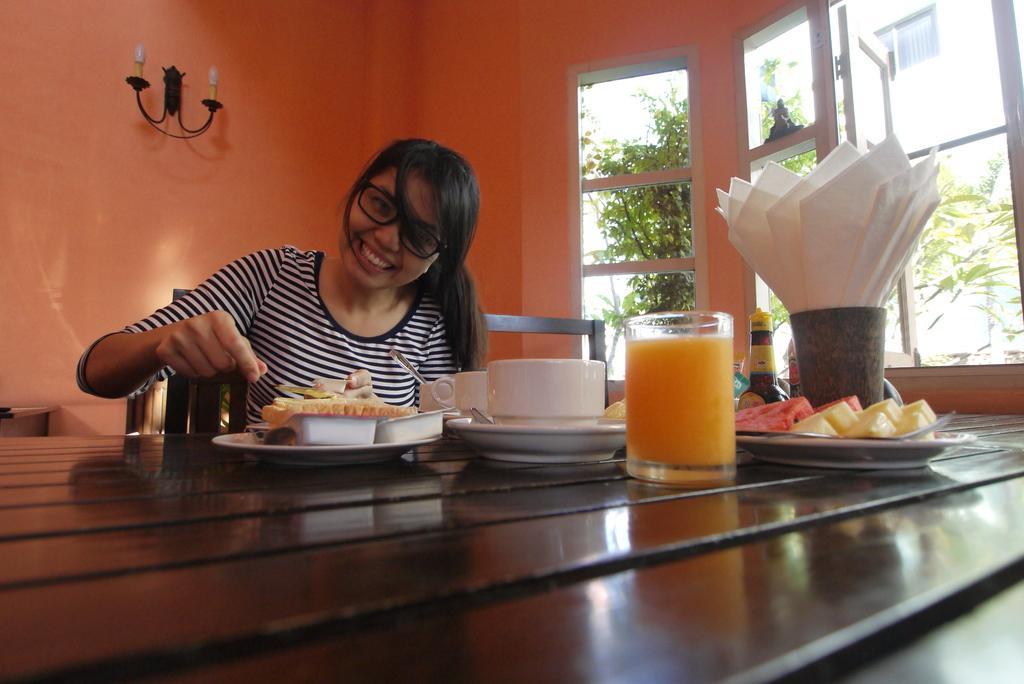Can you describe this image briefly? In this image I can see a person smiling and sitting in front of the table. On the table there is a glass,cup,plate with food. In the background there is a window and through the window I can see some plants. 